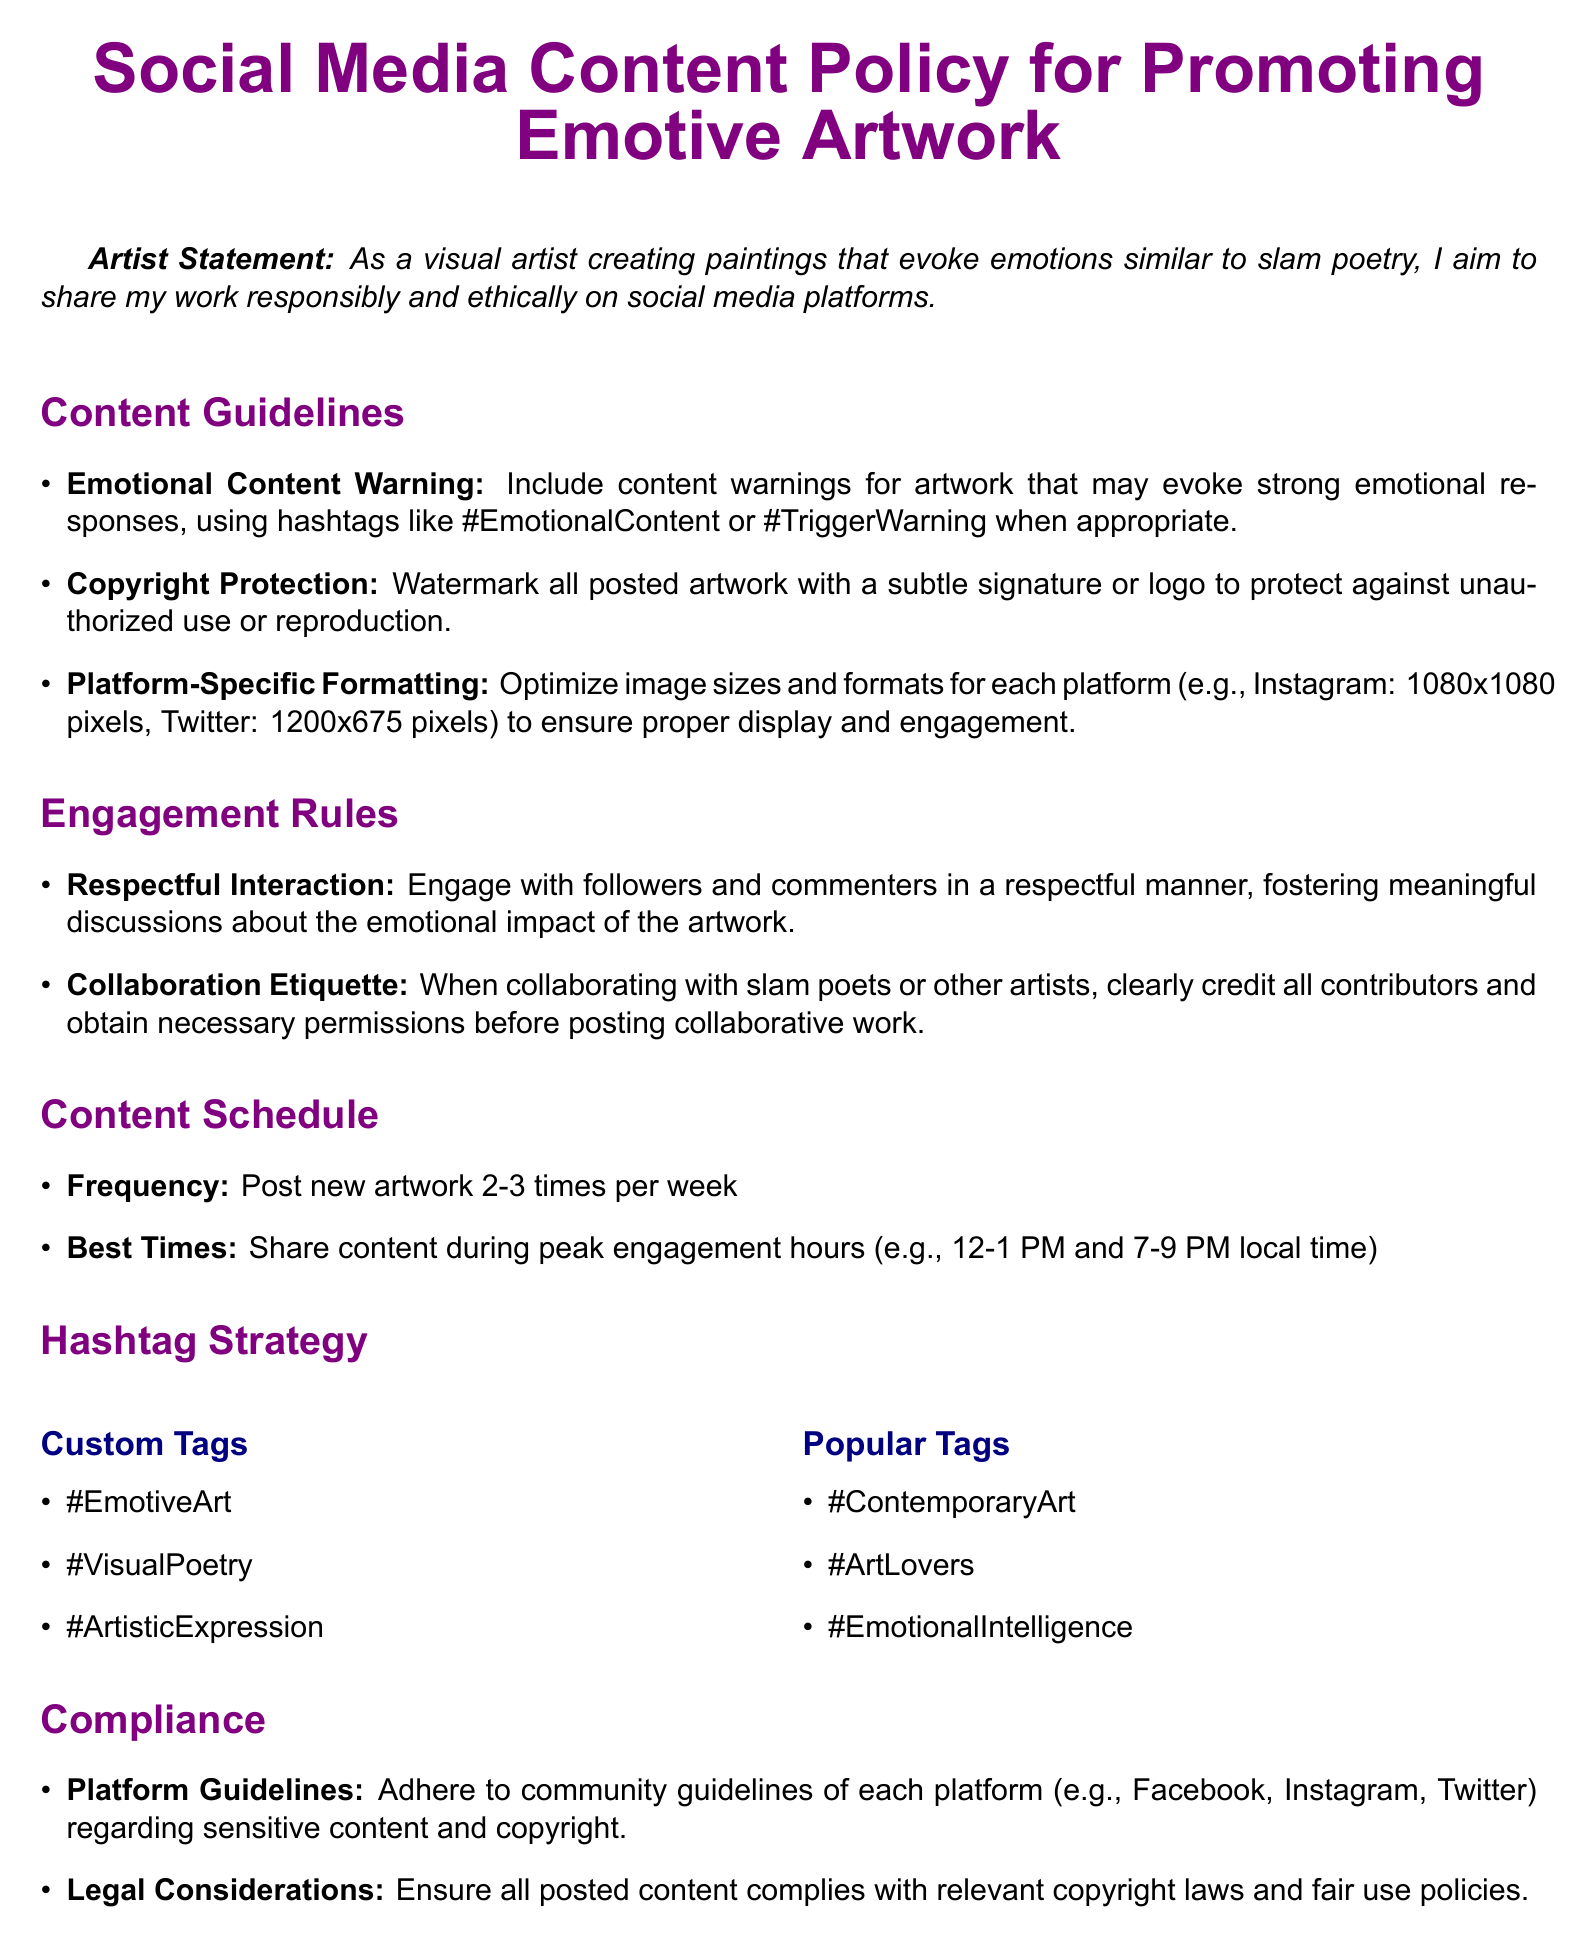What is the title of the document? The title is stated at the center of the document, which provides a clear indication of its subject matter.
Answer: Social Media Content Policy for Promoting Emotive Artwork How many times per week should new artwork be posted? The document specifies a recommended frequency for posting new artwork in the content schedule section.
Answer: 2-3 times What is the hashtag to indicate emotional content warnings? The document lists specific hashtags to use for various purposes, including emotional content warnings.
Answer: #TriggerWarning What is the optimal image size for posting on Instagram? The document outlines specific image sizes for different platforms and mentions the ideal size for Instagram explicitly.
Answer: 1080x1080 pixels What is required when collaborating with other artists? The engagement rules mention expectations for interaction when working with others, particularly crediting collaborators.
Answer: Credit all contributors What are the recommended peak engagement hours for posting? The content schedule section provides specific times that are best for sharing content to maximize engagement.
Answer: 12-1 PM and 7-9 PM What must be adhered to in terms of legal considerations? The compliance section highlights responsibilities regarding the legality of the posted content, which is crucial for artists.
Answer: Copyright laws What color is used for section titles? The document employs specific colors for stylistic elements, which can be found within the formatting rules.
Answer: Artpurple 